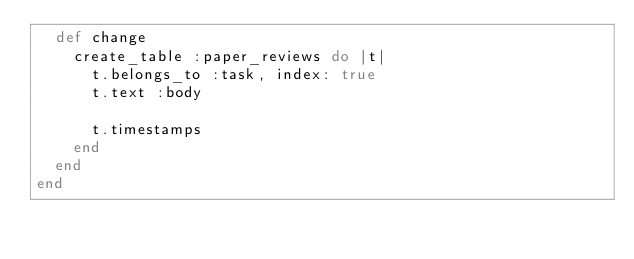<code> <loc_0><loc_0><loc_500><loc_500><_Ruby_>  def change
    create_table :paper_reviews do |t|
      t.belongs_to :task, index: true
      t.text :body

      t.timestamps
    end
  end
end
</code> 